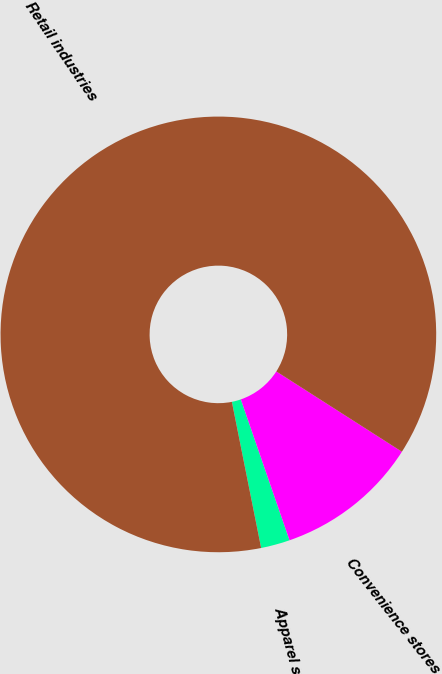Convert chart to OTSL. <chart><loc_0><loc_0><loc_500><loc_500><pie_chart><fcel>Apparel stores<fcel>Convenience stores<fcel>Retail industries<nl><fcel>2.15%<fcel>10.65%<fcel>87.19%<nl></chart> 